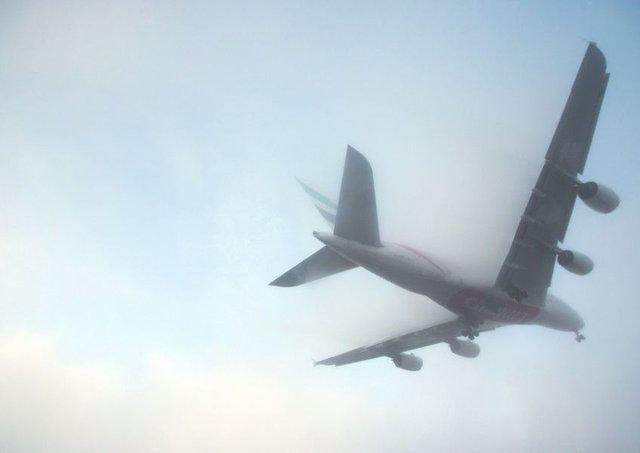What weather conditions are depicted around the airplane? The airplane is flying through what appears to be a misty or foggy condition. The haze surrounding the aircraft diffuses the light, which might indicate early morning or late afternoon timing, possibly creating challenges for visibility while enhancing the overall mystical appearance of the scene. 